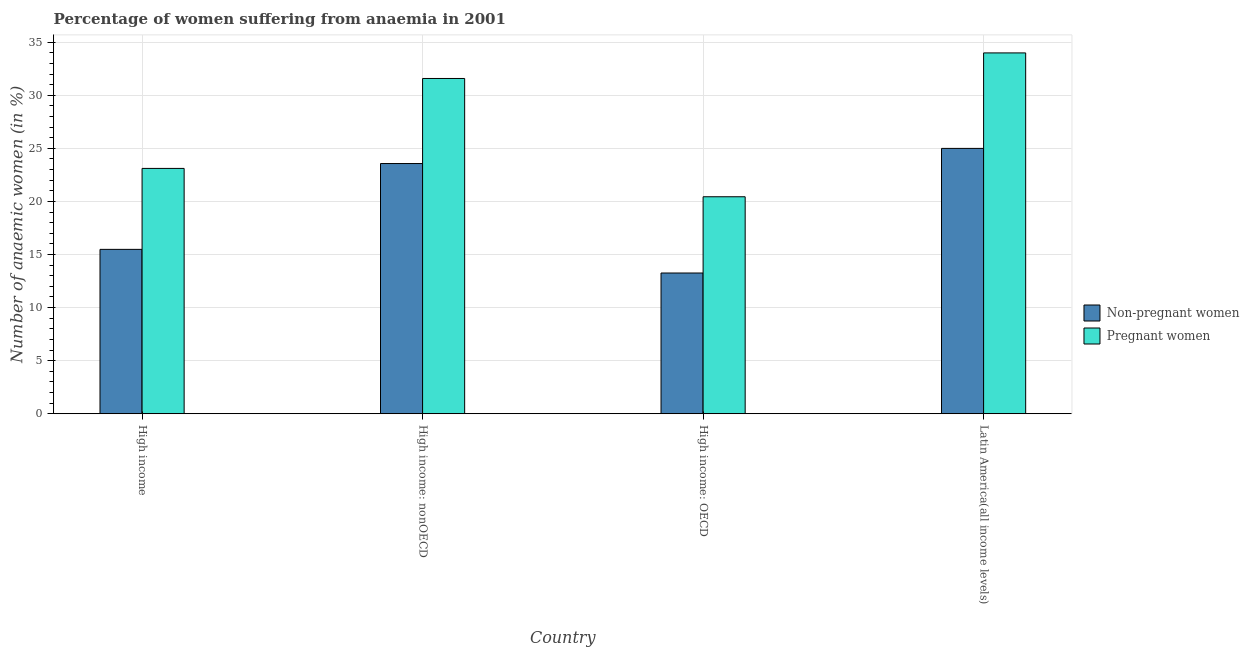How many different coloured bars are there?
Ensure brevity in your answer.  2. How many groups of bars are there?
Provide a succinct answer. 4. Are the number of bars on each tick of the X-axis equal?
Your answer should be compact. Yes. What is the label of the 3rd group of bars from the left?
Your answer should be compact. High income: OECD. In how many cases, is the number of bars for a given country not equal to the number of legend labels?
Ensure brevity in your answer.  0. What is the percentage of non-pregnant anaemic women in High income: OECD?
Offer a very short reply. 13.26. Across all countries, what is the maximum percentage of non-pregnant anaemic women?
Provide a succinct answer. 24.99. Across all countries, what is the minimum percentage of pregnant anaemic women?
Your response must be concise. 20.44. In which country was the percentage of non-pregnant anaemic women maximum?
Provide a succinct answer. Latin America(all income levels). In which country was the percentage of non-pregnant anaemic women minimum?
Offer a terse response. High income: OECD. What is the total percentage of pregnant anaemic women in the graph?
Your response must be concise. 109.12. What is the difference between the percentage of non-pregnant anaemic women in High income and that in High income: nonOECD?
Ensure brevity in your answer.  -8.09. What is the difference between the percentage of non-pregnant anaemic women in Latin America(all income levels) and the percentage of pregnant anaemic women in High income: nonOECD?
Ensure brevity in your answer.  -6.59. What is the average percentage of pregnant anaemic women per country?
Your answer should be compact. 27.28. What is the difference between the percentage of pregnant anaemic women and percentage of non-pregnant anaemic women in High income: nonOECD?
Ensure brevity in your answer.  8.01. What is the ratio of the percentage of non-pregnant anaemic women in High income to that in High income: nonOECD?
Make the answer very short. 0.66. Is the percentage of pregnant anaemic women in High income: nonOECD less than that in Latin America(all income levels)?
Offer a very short reply. Yes. Is the difference between the percentage of non-pregnant anaemic women in High income: OECD and Latin America(all income levels) greater than the difference between the percentage of pregnant anaemic women in High income: OECD and Latin America(all income levels)?
Give a very brief answer. Yes. What is the difference between the highest and the second highest percentage of pregnant anaemic women?
Provide a short and direct response. 2.41. What is the difference between the highest and the lowest percentage of pregnant anaemic women?
Offer a terse response. 13.55. In how many countries, is the percentage of pregnant anaemic women greater than the average percentage of pregnant anaemic women taken over all countries?
Provide a succinct answer. 2. What does the 2nd bar from the left in High income represents?
Your response must be concise. Pregnant women. What does the 1st bar from the right in High income: nonOECD represents?
Your answer should be compact. Pregnant women. Are all the bars in the graph horizontal?
Keep it short and to the point. No. What is the difference between two consecutive major ticks on the Y-axis?
Your answer should be compact. 5. Are the values on the major ticks of Y-axis written in scientific E-notation?
Your response must be concise. No. Does the graph contain any zero values?
Provide a succinct answer. No. Does the graph contain grids?
Give a very brief answer. Yes. Where does the legend appear in the graph?
Provide a succinct answer. Center right. How many legend labels are there?
Give a very brief answer. 2. How are the legend labels stacked?
Make the answer very short. Vertical. What is the title of the graph?
Make the answer very short. Percentage of women suffering from anaemia in 2001. What is the label or title of the Y-axis?
Make the answer very short. Number of anaemic women (in %). What is the Number of anaemic women (in %) of Non-pregnant women in High income?
Make the answer very short. 15.48. What is the Number of anaemic women (in %) in Pregnant women in High income?
Provide a succinct answer. 23.11. What is the Number of anaemic women (in %) of Non-pregnant women in High income: nonOECD?
Offer a very short reply. 23.57. What is the Number of anaemic women (in %) in Pregnant women in High income: nonOECD?
Provide a short and direct response. 31.58. What is the Number of anaemic women (in %) of Non-pregnant women in High income: OECD?
Your response must be concise. 13.26. What is the Number of anaemic women (in %) of Pregnant women in High income: OECD?
Your answer should be compact. 20.44. What is the Number of anaemic women (in %) in Non-pregnant women in Latin America(all income levels)?
Keep it short and to the point. 24.99. What is the Number of anaemic women (in %) of Pregnant women in Latin America(all income levels)?
Your answer should be compact. 33.99. Across all countries, what is the maximum Number of anaemic women (in %) of Non-pregnant women?
Provide a succinct answer. 24.99. Across all countries, what is the maximum Number of anaemic women (in %) of Pregnant women?
Make the answer very short. 33.99. Across all countries, what is the minimum Number of anaemic women (in %) in Non-pregnant women?
Your answer should be compact. 13.26. Across all countries, what is the minimum Number of anaemic women (in %) in Pregnant women?
Provide a short and direct response. 20.44. What is the total Number of anaemic women (in %) of Non-pregnant women in the graph?
Keep it short and to the point. 77.3. What is the total Number of anaemic women (in %) of Pregnant women in the graph?
Offer a very short reply. 109.12. What is the difference between the Number of anaemic women (in %) of Non-pregnant women in High income and that in High income: nonOECD?
Give a very brief answer. -8.09. What is the difference between the Number of anaemic women (in %) of Pregnant women in High income and that in High income: nonOECD?
Ensure brevity in your answer.  -8.47. What is the difference between the Number of anaemic women (in %) in Non-pregnant women in High income and that in High income: OECD?
Offer a very short reply. 2.23. What is the difference between the Number of anaemic women (in %) in Pregnant women in High income and that in High income: OECD?
Make the answer very short. 2.67. What is the difference between the Number of anaemic women (in %) of Non-pregnant women in High income and that in Latin America(all income levels)?
Make the answer very short. -9.51. What is the difference between the Number of anaemic women (in %) of Pregnant women in High income and that in Latin America(all income levels)?
Give a very brief answer. -10.88. What is the difference between the Number of anaemic women (in %) of Non-pregnant women in High income: nonOECD and that in High income: OECD?
Provide a succinct answer. 10.31. What is the difference between the Number of anaemic women (in %) in Pregnant women in High income: nonOECD and that in High income: OECD?
Your answer should be very brief. 11.14. What is the difference between the Number of anaemic women (in %) of Non-pregnant women in High income: nonOECD and that in Latin America(all income levels)?
Your response must be concise. -1.43. What is the difference between the Number of anaemic women (in %) of Pregnant women in High income: nonOECD and that in Latin America(all income levels)?
Give a very brief answer. -2.41. What is the difference between the Number of anaemic women (in %) in Non-pregnant women in High income: OECD and that in Latin America(all income levels)?
Your answer should be very brief. -11.74. What is the difference between the Number of anaemic women (in %) of Pregnant women in High income: OECD and that in Latin America(all income levels)?
Give a very brief answer. -13.55. What is the difference between the Number of anaemic women (in %) of Non-pregnant women in High income and the Number of anaemic women (in %) of Pregnant women in High income: nonOECD?
Your answer should be compact. -16.1. What is the difference between the Number of anaemic women (in %) of Non-pregnant women in High income and the Number of anaemic women (in %) of Pregnant women in High income: OECD?
Your answer should be very brief. -4.96. What is the difference between the Number of anaemic women (in %) in Non-pregnant women in High income and the Number of anaemic women (in %) in Pregnant women in Latin America(all income levels)?
Keep it short and to the point. -18.51. What is the difference between the Number of anaemic women (in %) of Non-pregnant women in High income: nonOECD and the Number of anaemic women (in %) of Pregnant women in High income: OECD?
Offer a terse response. 3.13. What is the difference between the Number of anaemic women (in %) of Non-pregnant women in High income: nonOECD and the Number of anaemic women (in %) of Pregnant women in Latin America(all income levels)?
Keep it short and to the point. -10.42. What is the difference between the Number of anaemic women (in %) in Non-pregnant women in High income: OECD and the Number of anaemic women (in %) in Pregnant women in Latin America(all income levels)?
Offer a very short reply. -20.73. What is the average Number of anaemic women (in %) in Non-pregnant women per country?
Ensure brevity in your answer.  19.33. What is the average Number of anaemic women (in %) of Pregnant women per country?
Give a very brief answer. 27.28. What is the difference between the Number of anaemic women (in %) in Non-pregnant women and Number of anaemic women (in %) in Pregnant women in High income?
Your answer should be very brief. -7.63. What is the difference between the Number of anaemic women (in %) of Non-pregnant women and Number of anaemic women (in %) of Pregnant women in High income: nonOECD?
Your answer should be very brief. -8.01. What is the difference between the Number of anaemic women (in %) of Non-pregnant women and Number of anaemic women (in %) of Pregnant women in High income: OECD?
Give a very brief answer. -7.18. What is the difference between the Number of anaemic women (in %) in Non-pregnant women and Number of anaemic women (in %) in Pregnant women in Latin America(all income levels)?
Make the answer very short. -8.99. What is the ratio of the Number of anaemic women (in %) in Non-pregnant women in High income to that in High income: nonOECD?
Make the answer very short. 0.66. What is the ratio of the Number of anaemic women (in %) of Pregnant women in High income to that in High income: nonOECD?
Offer a terse response. 0.73. What is the ratio of the Number of anaemic women (in %) of Non-pregnant women in High income to that in High income: OECD?
Ensure brevity in your answer.  1.17. What is the ratio of the Number of anaemic women (in %) of Pregnant women in High income to that in High income: OECD?
Your answer should be compact. 1.13. What is the ratio of the Number of anaemic women (in %) in Non-pregnant women in High income to that in Latin America(all income levels)?
Give a very brief answer. 0.62. What is the ratio of the Number of anaemic women (in %) in Pregnant women in High income to that in Latin America(all income levels)?
Your answer should be compact. 0.68. What is the ratio of the Number of anaemic women (in %) in Non-pregnant women in High income: nonOECD to that in High income: OECD?
Make the answer very short. 1.78. What is the ratio of the Number of anaemic women (in %) of Pregnant women in High income: nonOECD to that in High income: OECD?
Offer a terse response. 1.55. What is the ratio of the Number of anaemic women (in %) in Non-pregnant women in High income: nonOECD to that in Latin America(all income levels)?
Your answer should be very brief. 0.94. What is the ratio of the Number of anaemic women (in %) in Pregnant women in High income: nonOECD to that in Latin America(all income levels)?
Give a very brief answer. 0.93. What is the ratio of the Number of anaemic women (in %) of Non-pregnant women in High income: OECD to that in Latin America(all income levels)?
Offer a very short reply. 0.53. What is the ratio of the Number of anaemic women (in %) in Pregnant women in High income: OECD to that in Latin America(all income levels)?
Offer a very short reply. 0.6. What is the difference between the highest and the second highest Number of anaemic women (in %) of Non-pregnant women?
Your answer should be very brief. 1.43. What is the difference between the highest and the second highest Number of anaemic women (in %) in Pregnant women?
Your response must be concise. 2.41. What is the difference between the highest and the lowest Number of anaemic women (in %) of Non-pregnant women?
Give a very brief answer. 11.74. What is the difference between the highest and the lowest Number of anaemic women (in %) in Pregnant women?
Offer a terse response. 13.55. 